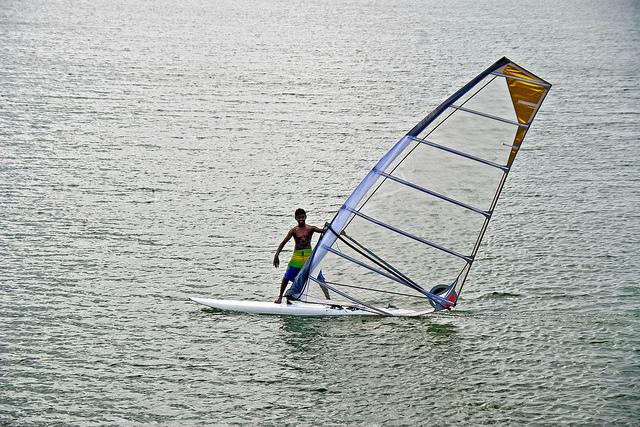Is that a man or woman?
Quick response, please. Man. Why is the man holding a blue rope?
Concise answer only. Sailing. What is the wheel for?
Short answer required. Water. Is that a cargo ship in the background?
Quick response, please. No. Is this water very rough?
Give a very brief answer. No. 